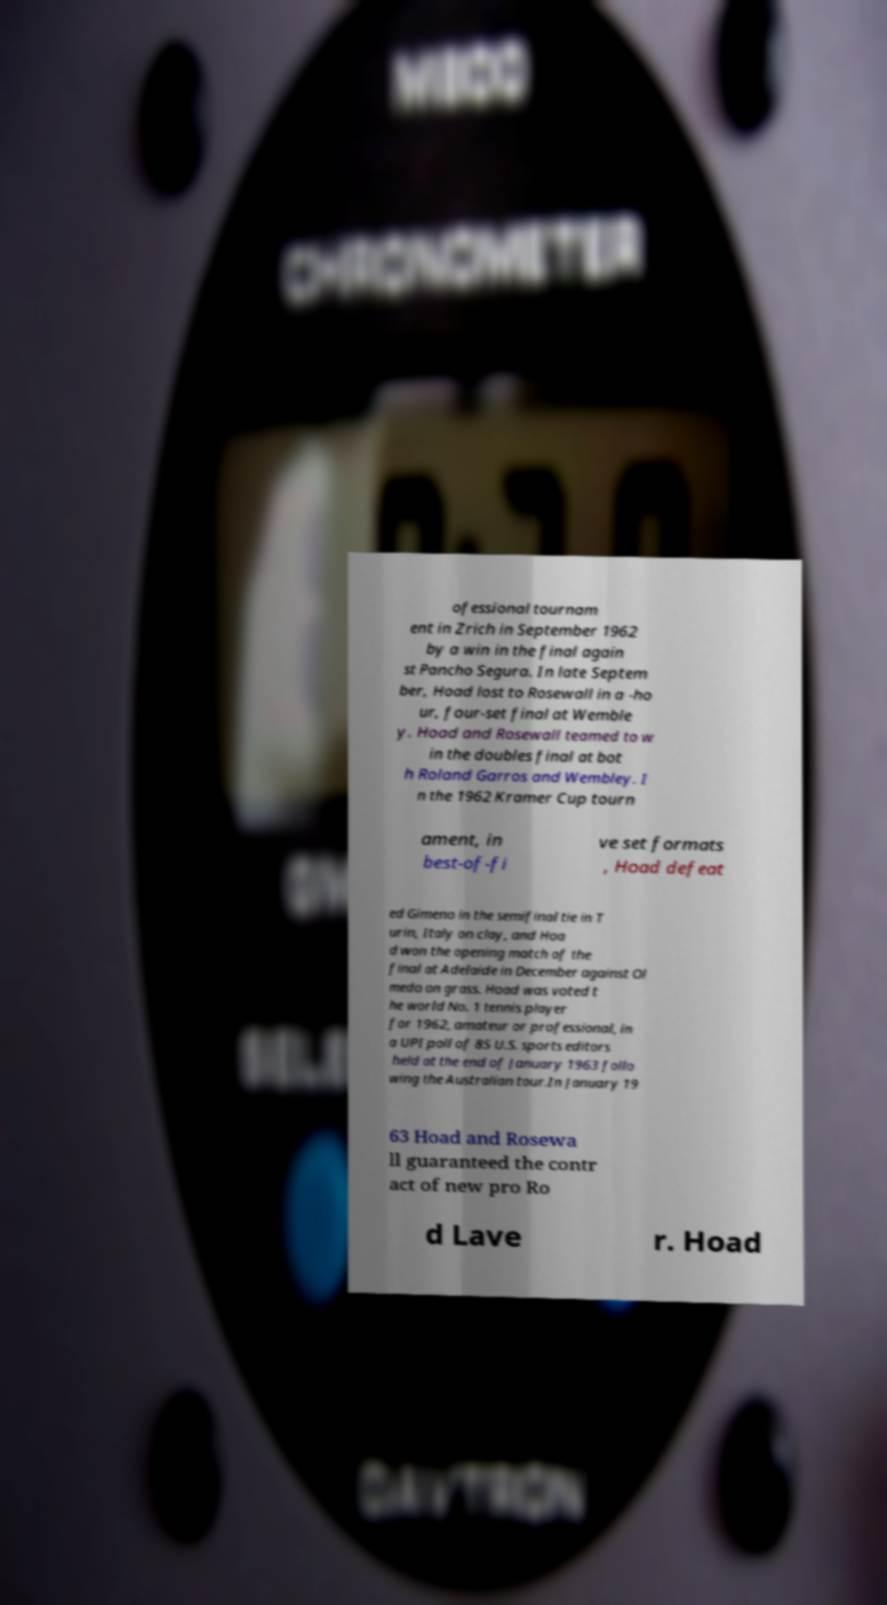There's text embedded in this image that I need extracted. Can you transcribe it verbatim? ofessional tournam ent in Zrich in September 1962 by a win in the final again st Pancho Segura. In late Septem ber, Hoad lost to Rosewall in a -ho ur, four-set final at Wemble y. Hoad and Rosewall teamed to w in the doubles final at bot h Roland Garros and Wembley. I n the 1962 Kramer Cup tourn ament, in best-of-fi ve set formats , Hoad defeat ed Gimeno in the semifinal tie in T urin, Italy on clay, and Hoa d won the opening match of the final at Adelaide in December against Ol medo on grass. Hoad was voted t he world No. 1 tennis player for 1962, amateur or professional, in a UPI poll of 85 U.S. sports editors held at the end of January 1963 follo wing the Australian tour.In January 19 63 Hoad and Rosewa ll guaranteed the contr act of new pro Ro d Lave r. Hoad 